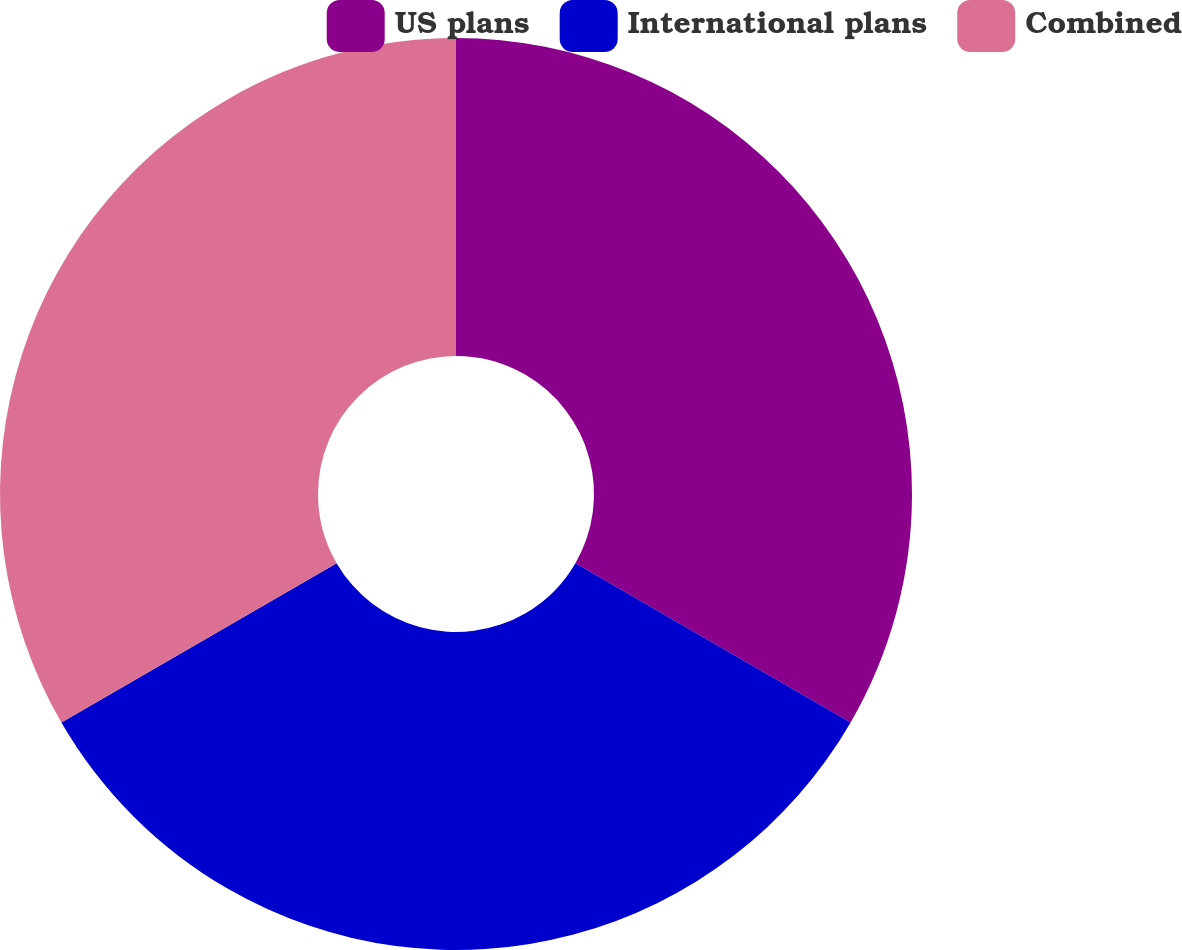Convert chart. <chart><loc_0><loc_0><loc_500><loc_500><pie_chart><fcel>US plans<fcel>International plans<fcel>Combined<nl><fcel>33.35%<fcel>33.29%<fcel>33.35%<nl></chart> 